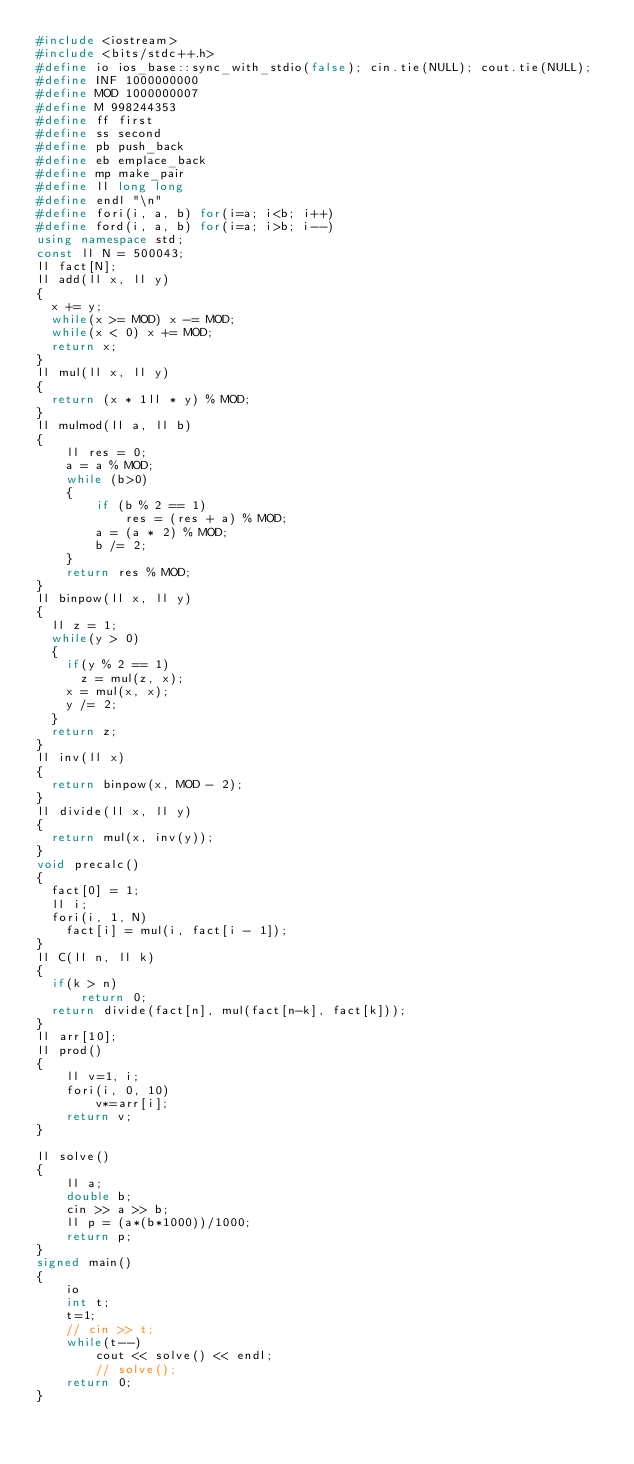<code> <loc_0><loc_0><loc_500><loc_500><_C++_>#include <iostream>
#include <bits/stdc++.h>
#define io ios_base::sync_with_stdio(false); cin.tie(NULL); cout.tie(NULL);
#define INF 1000000000
#define MOD 1000000007
#define M 998244353
#define ff first
#define ss second
#define pb push_back
#define eb emplace_back
#define mp make_pair
#define ll long long
#define endl "\n"
#define fori(i, a, b) for(i=a; i<b; i++)
#define ford(i, a, b) for(i=a; i>b; i--)
using namespace std;
const ll N = 500043;
ll fact[N];
ll add(ll x, ll y)
{
	x += y;
	while(x >= MOD) x -= MOD;
	while(x < 0) x += MOD;
	return x;
}
ll mul(ll x, ll y)
{
	return (x * 1ll * y) % MOD;
}
ll mulmod(ll a, ll b)
{
    ll res = 0;
    a = a % MOD;
    while (b>0)
    {
        if (b % 2 == 1)
            res = (res + a) % MOD;
        a = (a * 2) % MOD;
        b /= 2;
    }
    return res % MOD; 
}
ll binpow(ll x, ll y)
{
	ll z = 1;
	while(y > 0)
	{
		if(y % 2 == 1)
			z = mul(z, x);
		x = mul(x, x);
		y /= 2;
	}
	return z;
}
ll inv(ll x)
{
	return binpow(x, MOD - 2);
}
ll divide(ll x, ll y)
{
	return mul(x, inv(y));
}
void precalc()
{
	fact[0] = 1;
	ll i;
	fori(i, 1, N)
		fact[i] = mul(i, fact[i - 1]);
}
ll C(ll n, ll k)
{
	if(k > n)
	    return 0;
	return divide(fact[n], mul(fact[n-k], fact[k]));
}
ll arr[10];
ll prod()
{
    ll v=1, i;
    fori(i, 0, 10)
        v*=arr[i];
    return v;
}

ll solve()
{
    ll a;
    double b;
    cin >> a >> b;
    ll p = (a*(b*1000))/1000;
    return p;
}
signed main()
{
    io
    int t;
    t=1;
    // cin >> t;
    while(t--)
        cout << solve() << endl;
        // solve();
    return 0;
}</code> 